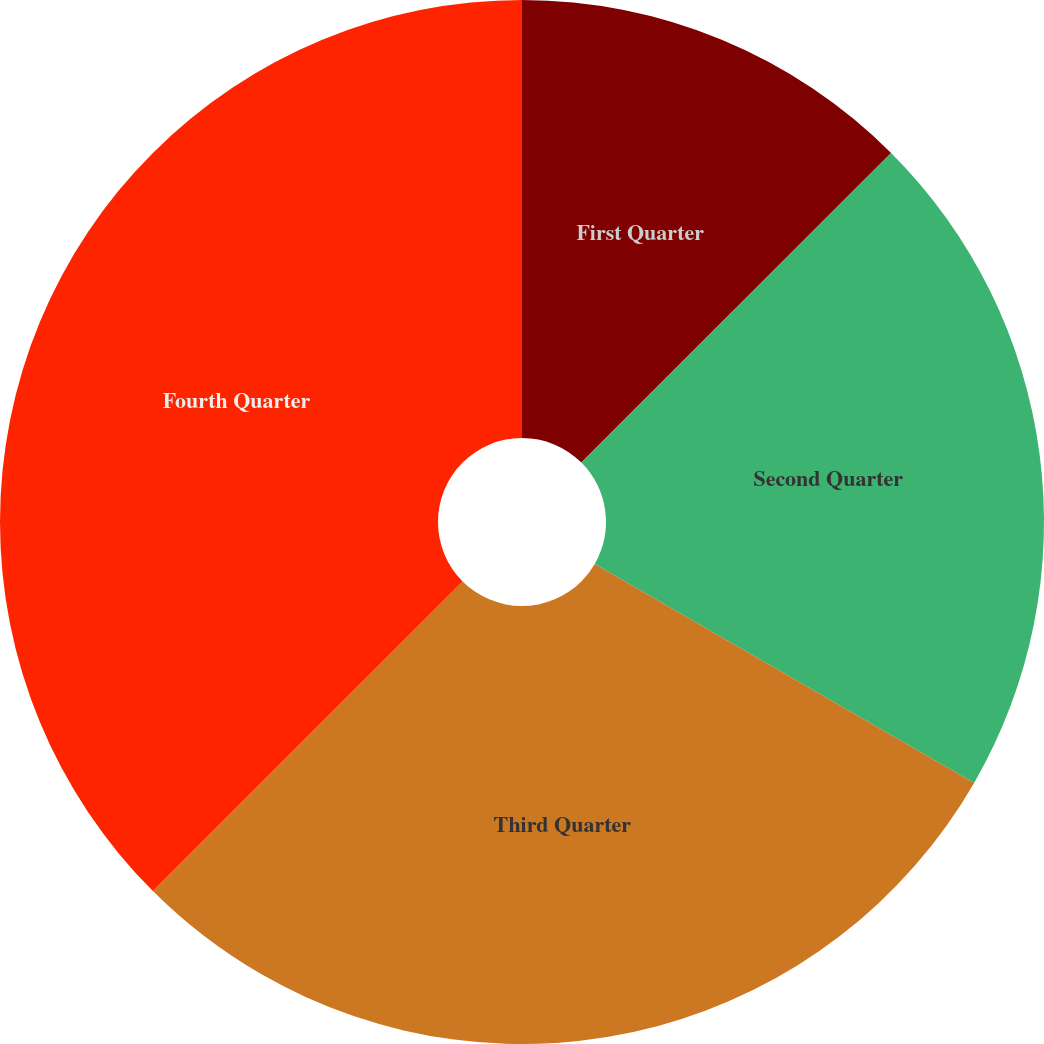<chart> <loc_0><loc_0><loc_500><loc_500><pie_chart><fcel>First Quarter<fcel>Second Quarter<fcel>Third Quarter<fcel>Fourth Quarter<nl><fcel>12.5%<fcel>20.83%<fcel>29.17%<fcel>37.5%<nl></chart> 